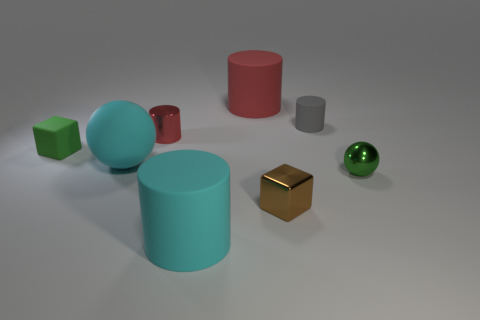Subtract 1 cylinders. How many cylinders are left? 3 Subtract all gray cylinders. How many cylinders are left? 3 Add 1 spheres. How many objects exist? 9 Subtract all blocks. How many objects are left? 6 Subtract 1 green blocks. How many objects are left? 7 Subtract all green matte cubes. Subtract all tiny spheres. How many objects are left? 6 Add 5 brown shiny cubes. How many brown shiny cubes are left? 6 Add 3 big red matte things. How many big red matte things exist? 4 